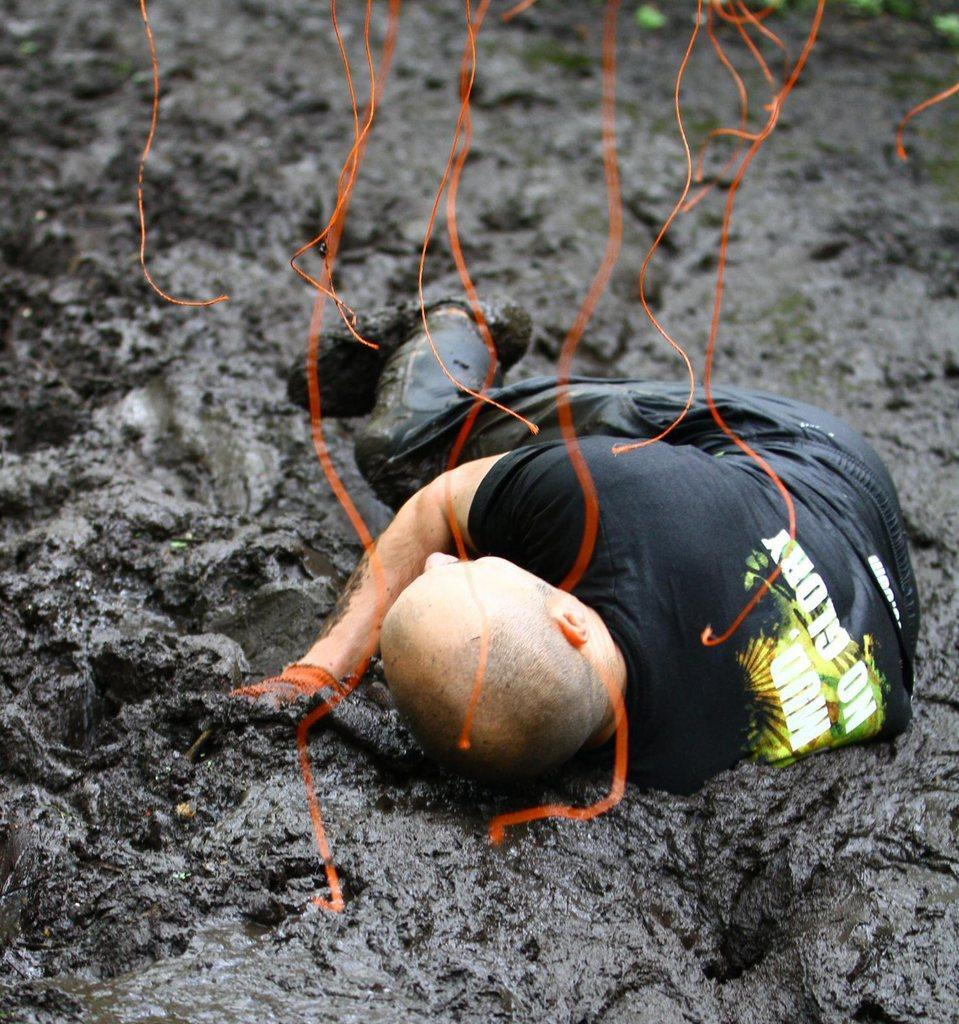Who or what is present in the image? There is a person in the image. What is the person's situation or environment? The person is in mud. Are there any additional elements or objects in the image? Yes, there are orange ribbons visible at the top of the image. How many beds are visible in the image? There are no beds present in the image. Are there any lizards crawling on the person in the image? There are no lizards visible in the image. 